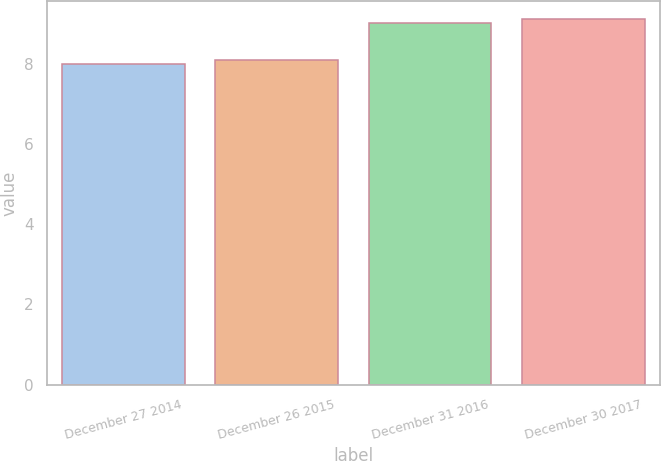Convert chart. <chart><loc_0><loc_0><loc_500><loc_500><bar_chart><fcel>December 27 2014<fcel>December 26 2015<fcel>December 31 2016<fcel>December 30 2017<nl><fcel>8<fcel>8.1<fcel>9<fcel>9.1<nl></chart> 